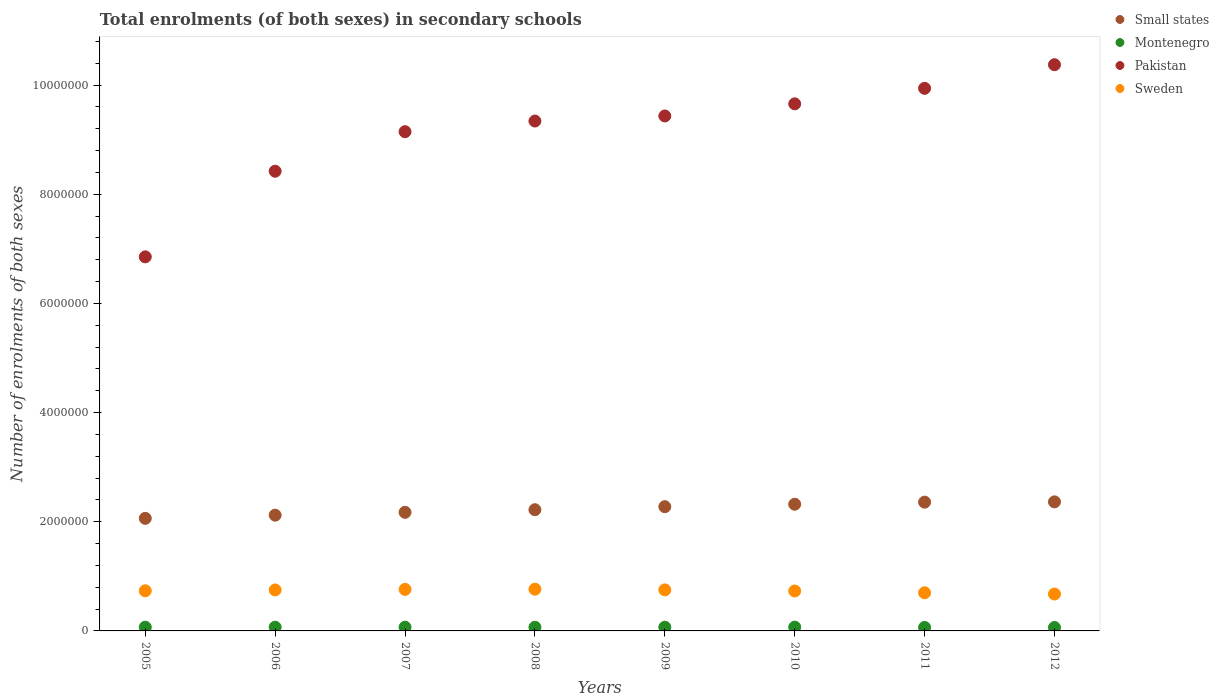How many different coloured dotlines are there?
Your response must be concise. 4. Is the number of dotlines equal to the number of legend labels?
Your answer should be compact. Yes. What is the number of enrolments in secondary schools in Small states in 2012?
Offer a terse response. 2.36e+06. Across all years, what is the maximum number of enrolments in secondary schools in Montenegro?
Keep it short and to the point. 6.96e+04. Across all years, what is the minimum number of enrolments in secondary schools in Pakistan?
Your response must be concise. 6.85e+06. In which year was the number of enrolments in secondary schools in Montenegro maximum?
Keep it short and to the point. 2010. In which year was the number of enrolments in secondary schools in Montenegro minimum?
Your answer should be very brief. 2012. What is the total number of enrolments in secondary schools in Small states in the graph?
Make the answer very short. 1.79e+07. What is the difference between the number of enrolments in secondary schools in Small states in 2006 and that in 2012?
Ensure brevity in your answer.  -2.44e+05. What is the difference between the number of enrolments in secondary schools in Pakistan in 2012 and the number of enrolments in secondary schools in Montenegro in 2009?
Provide a short and direct response. 1.03e+07. What is the average number of enrolments in secondary schools in Pakistan per year?
Your response must be concise. 9.14e+06. In the year 2006, what is the difference between the number of enrolments in secondary schools in Montenegro and number of enrolments in secondary schools in Small states?
Keep it short and to the point. -2.05e+06. In how many years, is the number of enrolments in secondary schools in Montenegro greater than 4400000?
Your answer should be very brief. 0. What is the ratio of the number of enrolments in secondary schools in Small states in 2007 to that in 2011?
Provide a short and direct response. 0.92. Is the number of enrolments in secondary schools in Montenegro in 2007 less than that in 2008?
Offer a terse response. No. What is the difference between the highest and the second highest number of enrolments in secondary schools in Sweden?
Your response must be concise. 3773. What is the difference between the highest and the lowest number of enrolments in secondary schools in Pakistan?
Provide a succinct answer. 3.52e+06. Is it the case that in every year, the sum of the number of enrolments in secondary schools in Montenegro and number of enrolments in secondary schools in Small states  is greater than the number of enrolments in secondary schools in Pakistan?
Give a very brief answer. No. Is the number of enrolments in secondary schools in Pakistan strictly less than the number of enrolments in secondary schools in Montenegro over the years?
Make the answer very short. No. How many dotlines are there?
Give a very brief answer. 4. Are the values on the major ticks of Y-axis written in scientific E-notation?
Keep it short and to the point. No. Does the graph contain any zero values?
Make the answer very short. No. How are the legend labels stacked?
Your answer should be compact. Vertical. What is the title of the graph?
Ensure brevity in your answer.  Total enrolments (of both sexes) in secondary schools. Does "Palau" appear as one of the legend labels in the graph?
Keep it short and to the point. No. What is the label or title of the X-axis?
Ensure brevity in your answer.  Years. What is the label or title of the Y-axis?
Offer a terse response. Number of enrolments of both sexes. What is the Number of enrolments of both sexes of Small states in 2005?
Offer a very short reply. 2.06e+06. What is the Number of enrolments of both sexes in Montenegro in 2005?
Keep it short and to the point. 6.85e+04. What is the Number of enrolments of both sexes in Pakistan in 2005?
Make the answer very short. 6.85e+06. What is the Number of enrolments of both sexes in Sweden in 2005?
Your answer should be compact. 7.35e+05. What is the Number of enrolments of both sexes in Small states in 2006?
Make the answer very short. 2.12e+06. What is the Number of enrolments of both sexes in Montenegro in 2006?
Keep it short and to the point. 6.82e+04. What is the Number of enrolments of both sexes in Pakistan in 2006?
Offer a very short reply. 8.42e+06. What is the Number of enrolments of both sexes in Sweden in 2006?
Give a very brief answer. 7.51e+05. What is the Number of enrolments of both sexes in Small states in 2007?
Offer a terse response. 2.17e+06. What is the Number of enrolments of both sexes of Montenegro in 2007?
Your answer should be very brief. 6.77e+04. What is the Number of enrolments of both sexes in Pakistan in 2007?
Your answer should be very brief. 9.15e+06. What is the Number of enrolments of both sexes of Sweden in 2007?
Offer a terse response. 7.60e+05. What is the Number of enrolments of both sexes in Small states in 2008?
Give a very brief answer. 2.22e+06. What is the Number of enrolments of both sexes in Montenegro in 2008?
Provide a succinct answer. 6.70e+04. What is the Number of enrolments of both sexes in Pakistan in 2008?
Your response must be concise. 9.34e+06. What is the Number of enrolments of both sexes of Sweden in 2008?
Offer a very short reply. 7.64e+05. What is the Number of enrolments of both sexes of Small states in 2009?
Make the answer very short. 2.28e+06. What is the Number of enrolments of both sexes in Montenegro in 2009?
Your answer should be compact. 6.81e+04. What is the Number of enrolments of both sexes in Pakistan in 2009?
Your answer should be very brief. 9.43e+06. What is the Number of enrolments of both sexes in Sweden in 2009?
Make the answer very short. 7.52e+05. What is the Number of enrolments of both sexes of Small states in 2010?
Offer a very short reply. 2.32e+06. What is the Number of enrolments of both sexes of Montenegro in 2010?
Your response must be concise. 6.96e+04. What is the Number of enrolments of both sexes of Pakistan in 2010?
Provide a short and direct response. 9.65e+06. What is the Number of enrolments of both sexes in Sweden in 2010?
Provide a succinct answer. 7.31e+05. What is the Number of enrolments of both sexes in Small states in 2011?
Keep it short and to the point. 2.36e+06. What is the Number of enrolments of both sexes of Montenegro in 2011?
Your answer should be compact. 6.42e+04. What is the Number of enrolments of both sexes in Pakistan in 2011?
Ensure brevity in your answer.  9.94e+06. What is the Number of enrolments of both sexes in Sweden in 2011?
Keep it short and to the point. 6.99e+05. What is the Number of enrolments of both sexes of Small states in 2012?
Offer a terse response. 2.36e+06. What is the Number of enrolments of both sexes of Montenegro in 2012?
Ensure brevity in your answer.  6.30e+04. What is the Number of enrolments of both sexes in Pakistan in 2012?
Ensure brevity in your answer.  1.04e+07. What is the Number of enrolments of both sexes of Sweden in 2012?
Give a very brief answer. 6.76e+05. Across all years, what is the maximum Number of enrolments of both sexes in Small states?
Offer a very short reply. 2.36e+06. Across all years, what is the maximum Number of enrolments of both sexes of Montenegro?
Keep it short and to the point. 6.96e+04. Across all years, what is the maximum Number of enrolments of both sexes of Pakistan?
Your answer should be very brief. 1.04e+07. Across all years, what is the maximum Number of enrolments of both sexes of Sweden?
Provide a succinct answer. 7.64e+05. Across all years, what is the minimum Number of enrolments of both sexes in Small states?
Make the answer very short. 2.06e+06. Across all years, what is the minimum Number of enrolments of both sexes of Montenegro?
Provide a succinct answer. 6.30e+04. Across all years, what is the minimum Number of enrolments of both sexes in Pakistan?
Offer a very short reply. 6.85e+06. Across all years, what is the minimum Number of enrolments of both sexes in Sweden?
Provide a succinct answer. 6.76e+05. What is the total Number of enrolments of both sexes in Small states in the graph?
Provide a short and direct response. 1.79e+07. What is the total Number of enrolments of both sexes of Montenegro in the graph?
Offer a very short reply. 5.36e+05. What is the total Number of enrolments of both sexes of Pakistan in the graph?
Provide a succinct answer. 7.32e+07. What is the total Number of enrolments of both sexes of Sweden in the graph?
Your answer should be compact. 5.87e+06. What is the difference between the Number of enrolments of both sexes of Small states in 2005 and that in 2006?
Your answer should be very brief. -5.83e+04. What is the difference between the Number of enrolments of both sexes of Montenegro in 2005 and that in 2006?
Provide a succinct answer. 253. What is the difference between the Number of enrolments of both sexes in Pakistan in 2005 and that in 2006?
Ensure brevity in your answer.  -1.57e+06. What is the difference between the Number of enrolments of both sexes of Sweden in 2005 and that in 2006?
Your answer should be compact. -1.51e+04. What is the difference between the Number of enrolments of both sexes of Small states in 2005 and that in 2007?
Give a very brief answer. -1.10e+05. What is the difference between the Number of enrolments of both sexes of Montenegro in 2005 and that in 2007?
Provide a succinct answer. 788. What is the difference between the Number of enrolments of both sexes in Pakistan in 2005 and that in 2007?
Your response must be concise. -2.29e+06. What is the difference between the Number of enrolments of both sexes in Sweden in 2005 and that in 2007?
Give a very brief answer. -2.50e+04. What is the difference between the Number of enrolments of both sexes in Small states in 2005 and that in 2008?
Provide a short and direct response. -1.58e+05. What is the difference between the Number of enrolments of both sexes of Montenegro in 2005 and that in 2008?
Keep it short and to the point. 1456. What is the difference between the Number of enrolments of both sexes of Pakistan in 2005 and that in 2008?
Your response must be concise. -2.49e+06. What is the difference between the Number of enrolments of both sexes in Sweden in 2005 and that in 2008?
Provide a short and direct response. -2.88e+04. What is the difference between the Number of enrolments of both sexes in Small states in 2005 and that in 2009?
Your answer should be very brief. -2.14e+05. What is the difference between the Number of enrolments of both sexes in Montenegro in 2005 and that in 2009?
Give a very brief answer. 336. What is the difference between the Number of enrolments of both sexes of Pakistan in 2005 and that in 2009?
Make the answer very short. -2.58e+06. What is the difference between the Number of enrolments of both sexes of Sweden in 2005 and that in 2009?
Your response must be concise. -1.63e+04. What is the difference between the Number of enrolments of both sexes of Small states in 2005 and that in 2010?
Your response must be concise. -2.59e+05. What is the difference between the Number of enrolments of both sexes of Montenegro in 2005 and that in 2010?
Your answer should be very brief. -1148. What is the difference between the Number of enrolments of both sexes of Pakistan in 2005 and that in 2010?
Ensure brevity in your answer.  -2.80e+06. What is the difference between the Number of enrolments of both sexes in Sweden in 2005 and that in 2010?
Keep it short and to the point. 4221. What is the difference between the Number of enrolments of both sexes in Small states in 2005 and that in 2011?
Provide a short and direct response. -2.97e+05. What is the difference between the Number of enrolments of both sexes of Montenegro in 2005 and that in 2011?
Give a very brief answer. 4307. What is the difference between the Number of enrolments of both sexes of Pakistan in 2005 and that in 2011?
Your answer should be very brief. -3.09e+06. What is the difference between the Number of enrolments of both sexes in Sweden in 2005 and that in 2011?
Your answer should be compact. 3.65e+04. What is the difference between the Number of enrolments of both sexes in Small states in 2005 and that in 2012?
Make the answer very short. -3.02e+05. What is the difference between the Number of enrolments of both sexes in Montenegro in 2005 and that in 2012?
Keep it short and to the point. 5458. What is the difference between the Number of enrolments of both sexes in Pakistan in 2005 and that in 2012?
Your answer should be compact. -3.52e+06. What is the difference between the Number of enrolments of both sexes of Sweden in 2005 and that in 2012?
Your response must be concise. 5.97e+04. What is the difference between the Number of enrolments of both sexes of Small states in 2006 and that in 2007?
Offer a terse response. -5.19e+04. What is the difference between the Number of enrolments of both sexes of Montenegro in 2006 and that in 2007?
Offer a terse response. 535. What is the difference between the Number of enrolments of both sexes of Pakistan in 2006 and that in 2007?
Provide a short and direct response. -7.24e+05. What is the difference between the Number of enrolments of both sexes of Sweden in 2006 and that in 2007?
Provide a short and direct response. -9924. What is the difference between the Number of enrolments of both sexes of Small states in 2006 and that in 2008?
Offer a very short reply. -9.96e+04. What is the difference between the Number of enrolments of both sexes in Montenegro in 2006 and that in 2008?
Offer a very short reply. 1203. What is the difference between the Number of enrolments of both sexes of Pakistan in 2006 and that in 2008?
Keep it short and to the point. -9.19e+05. What is the difference between the Number of enrolments of both sexes of Sweden in 2006 and that in 2008?
Offer a very short reply. -1.37e+04. What is the difference between the Number of enrolments of both sexes of Small states in 2006 and that in 2009?
Provide a succinct answer. -1.55e+05. What is the difference between the Number of enrolments of both sexes in Montenegro in 2006 and that in 2009?
Your answer should be very brief. 83. What is the difference between the Number of enrolments of both sexes of Pakistan in 2006 and that in 2009?
Provide a succinct answer. -1.01e+06. What is the difference between the Number of enrolments of both sexes in Sweden in 2006 and that in 2009?
Ensure brevity in your answer.  -1259. What is the difference between the Number of enrolments of both sexes of Small states in 2006 and that in 2010?
Offer a very short reply. -2.00e+05. What is the difference between the Number of enrolments of both sexes of Montenegro in 2006 and that in 2010?
Offer a terse response. -1401. What is the difference between the Number of enrolments of both sexes of Pakistan in 2006 and that in 2010?
Provide a short and direct response. -1.23e+06. What is the difference between the Number of enrolments of both sexes of Sweden in 2006 and that in 2010?
Your answer should be compact. 1.93e+04. What is the difference between the Number of enrolments of both sexes of Small states in 2006 and that in 2011?
Provide a short and direct response. -2.38e+05. What is the difference between the Number of enrolments of both sexes in Montenegro in 2006 and that in 2011?
Provide a succinct answer. 4054. What is the difference between the Number of enrolments of both sexes in Pakistan in 2006 and that in 2011?
Your answer should be very brief. -1.52e+06. What is the difference between the Number of enrolments of both sexes of Sweden in 2006 and that in 2011?
Ensure brevity in your answer.  5.16e+04. What is the difference between the Number of enrolments of both sexes in Small states in 2006 and that in 2012?
Offer a terse response. -2.44e+05. What is the difference between the Number of enrolments of both sexes of Montenegro in 2006 and that in 2012?
Your response must be concise. 5205. What is the difference between the Number of enrolments of both sexes of Pakistan in 2006 and that in 2012?
Offer a very short reply. -1.95e+06. What is the difference between the Number of enrolments of both sexes of Sweden in 2006 and that in 2012?
Provide a succinct answer. 7.48e+04. What is the difference between the Number of enrolments of both sexes of Small states in 2007 and that in 2008?
Give a very brief answer. -4.77e+04. What is the difference between the Number of enrolments of both sexes of Montenegro in 2007 and that in 2008?
Offer a very short reply. 668. What is the difference between the Number of enrolments of both sexes in Pakistan in 2007 and that in 2008?
Ensure brevity in your answer.  -1.95e+05. What is the difference between the Number of enrolments of both sexes of Sweden in 2007 and that in 2008?
Offer a terse response. -3773. What is the difference between the Number of enrolments of both sexes of Small states in 2007 and that in 2009?
Provide a short and direct response. -1.03e+05. What is the difference between the Number of enrolments of both sexes in Montenegro in 2007 and that in 2009?
Give a very brief answer. -452. What is the difference between the Number of enrolments of both sexes in Pakistan in 2007 and that in 2009?
Provide a succinct answer. -2.88e+05. What is the difference between the Number of enrolments of both sexes of Sweden in 2007 and that in 2009?
Keep it short and to the point. 8665. What is the difference between the Number of enrolments of both sexes in Small states in 2007 and that in 2010?
Provide a short and direct response. -1.48e+05. What is the difference between the Number of enrolments of both sexes in Montenegro in 2007 and that in 2010?
Give a very brief answer. -1936. What is the difference between the Number of enrolments of both sexes in Pakistan in 2007 and that in 2010?
Offer a very short reply. -5.10e+05. What is the difference between the Number of enrolments of both sexes in Sweden in 2007 and that in 2010?
Give a very brief answer. 2.92e+04. What is the difference between the Number of enrolments of both sexes of Small states in 2007 and that in 2011?
Your answer should be very brief. -1.86e+05. What is the difference between the Number of enrolments of both sexes of Montenegro in 2007 and that in 2011?
Your answer should be compact. 3519. What is the difference between the Number of enrolments of both sexes of Pakistan in 2007 and that in 2011?
Your response must be concise. -7.94e+05. What is the difference between the Number of enrolments of both sexes of Sweden in 2007 and that in 2011?
Your answer should be compact. 6.15e+04. What is the difference between the Number of enrolments of both sexes in Small states in 2007 and that in 2012?
Give a very brief answer. -1.92e+05. What is the difference between the Number of enrolments of both sexes of Montenegro in 2007 and that in 2012?
Your answer should be compact. 4670. What is the difference between the Number of enrolments of both sexes of Pakistan in 2007 and that in 2012?
Offer a very short reply. -1.23e+06. What is the difference between the Number of enrolments of both sexes in Sweden in 2007 and that in 2012?
Your answer should be very brief. 8.47e+04. What is the difference between the Number of enrolments of both sexes in Small states in 2008 and that in 2009?
Your answer should be compact. -5.58e+04. What is the difference between the Number of enrolments of both sexes of Montenegro in 2008 and that in 2009?
Offer a terse response. -1120. What is the difference between the Number of enrolments of both sexes of Pakistan in 2008 and that in 2009?
Provide a succinct answer. -9.30e+04. What is the difference between the Number of enrolments of both sexes of Sweden in 2008 and that in 2009?
Your response must be concise. 1.24e+04. What is the difference between the Number of enrolments of both sexes in Small states in 2008 and that in 2010?
Offer a terse response. -1.01e+05. What is the difference between the Number of enrolments of both sexes in Montenegro in 2008 and that in 2010?
Offer a terse response. -2604. What is the difference between the Number of enrolments of both sexes of Pakistan in 2008 and that in 2010?
Your answer should be very brief. -3.15e+05. What is the difference between the Number of enrolments of both sexes in Sweden in 2008 and that in 2010?
Keep it short and to the point. 3.30e+04. What is the difference between the Number of enrolments of both sexes in Small states in 2008 and that in 2011?
Your answer should be compact. -1.39e+05. What is the difference between the Number of enrolments of both sexes of Montenegro in 2008 and that in 2011?
Keep it short and to the point. 2851. What is the difference between the Number of enrolments of both sexes in Pakistan in 2008 and that in 2011?
Keep it short and to the point. -5.99e+05. What is the difference between the Number of enrolments of both sexes in Sweden in 2008 and that in 2011?
Offer a terse response. 6.53e+04. What is the difference between the Number of enrolments of both sexes in Small states in 2008 and that in 2012?
Offer a very short reply. -1.44e+05. What is the difference between the Number of enrolments of both sexes of Montenegro in 2008 and that in 2012?
Keep it short and to the point. 4002. What is the difference between the Number of enrolments of both sexes of Pakistan in 2008 and that in 2012?
Offer a terse response. -1.03e+06. What is the difference between the Number of enrolments of both sexes of Sweden in 2008 and that in 2012?
Make the answer very short. 8.85e+04. What is the difference between the Number of enrolments of both sexes in Small states in 2009 and that in 2010?
Keep it short and to the point. -4.49e+04. What is the difference between the Number of enrolments of both sexes in Montenegro in 2009 and that in 2010?
Ensure brevity in your answer.  -1484. What is the difference between the Number of enrolments of both sexes of Pakistan in 2009 and that in 2010?
Ensure brevity in your answer.  -2.22e+05. What is the difference between the Number of enrolments of both sexes of Sweden in 2009 and that in 2010?
Provide a succinct answer. 2.06e+04. What is the difference between the Number of enrolments of both sexes in Small states in 2009 and that in 2011?
Give a very brief answer. -8.30e+04. What is the difference between the Number of enrolments of both sexes in Montenegro in 2009 and that in 2011?
Make the answer very short. 3971. What is the difference between the Number of enrolments of both sexes of Pakistan in 2009 and that in 2011?
Offer a very short reply. -5.06e+05. What is the difference between the Number of enrolments of both sexes in Sweden in 2009 and that in 2011?
Provide a succinct answer. 5.29e+04. What is the difference between the Number of enrolments of both sexes in Small states in 2009 and that in 2012?
Your answer should be very brief. -8.83e+04. What is the difference between the Number of enrolments of both sexes in Montenegro in 2009 and that in 2012?
Offer a very short reply. 5122. What is the difference between the Number of enrolments of both sexes in Pakistan in 2009 and that in 2012?
Your answer should be very brief. -9.39e+05. What is the difference between the Number of enrolments of both sexes of Sweden in 2009 and that in 2012?
Offer a very short reply. 7.60e+04. What is the difference between the Number of enrolments of both sexes of Small states in 2010 and that in 2011?
Provide a succinct answer. -3.81e+04. What is the difference between the Number of enrolments of both sexes of Montenegro in 2010 and that in 2011?
Keep it short and to the point. 5455. What is the difference between the Number of enrolments of both sexes of Pakistan in 2010 and that in 2011?
Make the answer very short. -2.84e+05. What is the difference between the Number of enrolments of both sexes of Sweden in 2010 and that in 2011?
Your answer should be very brief. 3.23e+04. What is the difference between the Number of enrolments of both sexes in Small states in 2010 and that in 2012?
Your answer should be compact. -4.35e+04. What is the difference between the Number of enrolments of both sexes in Montenegro in 2010 and that in 2012?
Your answer should be very brief. 6606. What is the difference between the Number of enrolments of both sexes in Pakistan in 2010 and that in 2012?
Your answer should be compact. -7.17e+05. What is the difference between the Number of enrolments of both sexes in Sweden in 2010 and that in 2012?
Make the answer very short. 5.55e+04. What is the difference between the Number of enrolments of both sexes of Small states in 2011 and that in 2012?
Provide a short and direct response. -5352.25. What is the difference between the Number of enrolments of both sexes in Montenegro in 2011 and that in 2012?
Your answer should be very brief. 1151. What is the difference between the Number of enrolments of both sexes in Pakistan in 2011 and that in 2012?
Your answer should be very brief. -4.32e+05. What is the difference between the Number of enrolments of both sexes of Sweden in 2011 and that in 2012?
Make the answer very short. 2.32e+04. What is the difference between the Number of enrolments of both sexes in Small states in 2005 and the Number of enrolments of both sexes in Montenegro in 2006?
Provide a succinct answer. 1.99e+06. What is the difference between the Number of enrolments of both sexes in Small states in 2005 and the Number of enrolments of both sexes in Pakistan in 2006?
Your answer should be compact. -6.36e+06. What is the difference between the Number of enrolments of both sexes of Small states in 2005 and the Number of enrolments of both sexes of Sweden in 2006?
Your answer should be compact. 1.31e+06. What is the difference between the Number of enrolments of both sexes in Montenegro in 2005 and the Number of enrolments of both sexes in Pakistan in 2006?
Your answer should be compact. -8.35e+06. What is the difference between the Number of enrolments of both sexes in Montenegro in 2005 and the Number of enrolments of both sexes in Sweden in 2006?
Offer a very short reply. -6.82e+05. What is the difference between the Number of enrolments of both sexes in Pakistan in 2005 and the Number of enrolments of both sexes in Sweden in 2006?
Your answer should be compact. 6.10e+06. What is the difference between the Number of enrolments of both sexes in Small states in 2005 and the Number of enrolments of both sexes in Montenegro in 2007?
Your response must be concise. 1.99e+06. What is the difference between the Number of enrolments of both sexes of Small states in 2005 and the Number of enrolments of both sexes of Pakistan in 2007?
Provide a short and direct response. -7.08e+06. What is the difference between the Number of enrolments of both sexes in Small states in 2005 and the Number of enrolments of both sexes in Sweden in 2007?
Provide a succinct answer. 1.30e+06. What is the difference between the Number of enrolments of both sexes in Montenegro in 2005 and the Number of enrolments of both sexes in Pakistan in 2007?
Offer a terse response. -9.08e+06. What is the difference between the Number of enrolments of both sexes in Montenegro in 2005 and the Number of enrolments of both sexes in Sweden in 2007?
Keep it short and to the point. -6.92e+05. What is the difference between the Number of enrolments of both sexes of Pakistan in 2005 and the Number of enrolments of both sexes of Sweden in 2007?
Provide a succinct answer. 6.09e+06. What is the difference between the Number of enrolments of both sexes of Small states in 2005 and the Number of enrolments of both sexes of Montenegro in 2008?
Make the answer very short. 2.00e+06. What is the difference between the Number of enrolments of both sexes of Small states in 2005 and the Number of enrolments of both sexes of Pakistan in 2008?
Your response must be concise. -7.28e+06. What is the difference between the Number of enrolments of both sexes in Small states in 2005 and the Number of enrolments of both sexes in Sweden in 2008?
Your answer should be very brief. 1.30e+06. What is the difference between the Number of enrolments of both sexes in Montenegro in 2005 and the Number of enrolments of both sexes in Pakistan in 2008?
Your response must be concise. -9.27e+06. What is the difference between the Number of enrolments of both sexes of Montenegro in 2005 and the Number of enrolments of both sexes of Sweden in 2008?
Provide a short and direct response. -6.96e+05. What is the difference between the Number of enrolments of both sexes of Pakistan in 2005 and the Number of enrolments of both sexes of Sweden in 2008?
Your answer should be very brief. 6.09e+06. What is the difference between the Number of enrolments of both sexes in Small states in 2005 and the Number of enrolments of both sexes in Montenegro in 2009?
Ensure brevity in your answer.  1.99e+06. What is the difference between the Number of enrolments of both sexes of Small states in 2005 and the Number of enrolments of both sexes of Pakistan in 2009?
Ensure brevity in your answer.  -7.37e+06. What is the difference between the Number of enrolments of both sexes of Small states in 2005 and the Number of enrolments of both sexes of Sweden in 2009?
Offer a very short reply. 1.31e+06. What is the difference between the Number of enrolments of both sexes in Montenegro in 2005 and the Number of enrolments of both sexes in Pakistan in 2009?
Keep it short and to the point. -9.36e+06. What is the difference between the Number of enrolments of both sexes of Montenegro in 2005 and the Number of enrolments of both sexes of Sweden in 2009?
Give a very brief answer. -6.83e+05. What is the difference between the Number of enrolments of both sexes of Pakistan in 2005 and the Number of enrolments of both sexes of Sweden in 2009?
Provide a short and direct response. 6.10e+06. What is the difference between the Number of enrolments of both sexes in Small states in 2005 and the Number of enrolments of both sexes in Montenegro in 2010?
Keep it short and to the point. 1.99e+06. What is the difference between the Number of enrolments of both sexes of Small states in 2005 and the Number of enrolments of both sexes of Pakistan in 2010?
Your answer should be very brief. -7.59e+06. What is the difference between the Number of enrolments of both sexes in Small states in 2005 and the Number of enrolments of both sexes in Sweden in 2010?
Ensure brevity in your answer.  1.33e+06. What is the difference between the Number of enrolments of both sexes of Montenegro in 2005 and the Number of enrolments of both sexes of Pakistan in 2010?
Keep it short and to the point. -9.59e+06. What is the difference between the Number of enrolments of both sexes of Montenegro in 2005 and the Number of enrolments of both sexes of Sweden in 2010?
Your answer should be compact. -6.63e+05. What is the difference between the Number of enrolments of both sexes of Pakistan in 2005 and the Number of enrolments of both sexes of Sweden in 2010?
Offer a very short reply. 6.12e+06. What is the difference between the Number of enrolments of both sexes of Small states in 2005 and the Number of enrolments of both sexes of Montenegro in 2011?
Offer a terse response. 2.00e+06. What is the difference between the Number of enrolments of both sexes of Small states in 2005 and the Number of enrolments of both sexes of Pakistan in 2011?
Offer a very short reply. -7.88e+06. What is the difference between the Number of enrolments of both sexes in Small states in 2005 and the Number of enrolments of both sexes in Sweden in 2011?
Your response must be concise. 1.36e+06. What is the difference between the Number of enrolments of both sexes of Montenegro in 2005 and the Number of enrolments of both sexes of Pakistan in 2011?
Ensure brevity in your answer.  -9.87e+06. What is the difference between the Number of enrolments of both sexes of Montenegro in 2005 and the Number of enrolments of both sexes of Sweden in 2011?
Ensure brevity in your answer.  -6.30e+05. What is the difference between the Number of enrolments of both sexes in Pakistan in 2005 and the Number of enrolments of both sexes in Sweden in 2011?
Provide a short and direct response. 6.15e+06. What is the difference between the Number of enrolments of both sexes of Small states in 2005 and the Number of enrolments of both sexes of Montenegro in 2012?
Make the answer very short. 2.00e+06. What is the difference between the Number of enrolments of both sexes in Small states in 2005 and the Number of enrolments of both sexes in Pakistan in 2012?
Give a very brief answer. -8.31e+06. What is the difference between the Number of enrolments of both sexes of Small states in 2005 and the Number of enrolments of both sexes of Sweden in 2012?
Provide a short and direct response. 1.39e+06. What is the difference between the Number of enrolments of both sexes of Montenegro in 2005 and the Number of enrolments of both sexes of Pakistan in 2012?
Ensure brevity in your answer.  -1.03e+07. What is the difference between the Number of enrolments of both sexes in Montenegro in 2005 and the Number of enrolments of both sexes in Sweden in 2012?
Offer a terse response. -6.07e+05. What is the difference between the Number of enrolments of both sexes in Pakistan in 2005 and the Number of enrolments of both sexes in Sweden in 2012?
Offer a very short reply. 6.18e+06. What is the difference between the Number of enrolments of both sexes in Small states in 2006 and the Number of enrolments of both sexes in Montenegro in 2007?
Give a very brief answer. 2.05e+06. What is the difference between the Number of enrolments of both sexes in Small states in 2006 and the Number of enrolments of both sexes in Pakistan in 2007?
Provide a short and direct response. -7.02e+06. What is the difference between the Number of enrolments of both sexes of Small states in 2006 and the Number of enrolments of both sexes of Sweden in 2007?
Your answer should be compact. 1.36e+06. What is the difference between the Number of enrolments of both sexes of Montenegro in 2006 and the Number of enrolments of both sexes of Pakistan in 2007?
Provide a short and direct response. -9.08e+06. What is the difference between the Number of enrolments of both sexes in Montenegro in 2006 and the Number of enrolments of both sexes in Sweden in 2007?
Your answer should be very brief. -6.92e+05. What is the difference between the Number of enrolments of both sexes in Pakistan in 2006 and the Number of enrolments of both sexes in Sweden in 2007?
Provide a succinct answer. 7.66e+06. What is the difference between the Number of enrolments of both sexes of Small states in 2006 and the Number of enrolments of both sexes of Montenegro in 2008?
Give a very brief answer. 2.05e+06. What is the difference between the Number of enrolments of both sexes of Small states in 2006 and the Number of enrolments of both sexes of Pakistan in 2008?
Make the answer very short. -7.22e+06. What is the difference between the Number of enrolments of both sexes of Small states in 2006 and the Number of enrolments of both sexes of Sweden in 2008?
Your answer should be very brief. 1.36e+06. What is the difference between the Number of enrolments of both sexes in Montenegro in 2006 and the Number of enrolments of both sexes in Pakistan in 2008?
Ensure brevity in your answer.  -9.27e+06. What is the difference between the Number of enrolments of both sexes of Montenegro in 2006 and the Number of enrolments of both sexes of Sweden in 2008?
Keep it short and to the point. -6.96e+05. What is the difference between the Number of enrolments of both sexes of Pakistan in 2006 and the Number of enrolments of both sexes of Sweden in 2008?
Your answer should be very brief. 7.66e+06. What is the difference between the Number of enrolments of both sexes of Small states in 2006 and the Number of enrolments of both sexes of Montenegro in 2009?
Ensure brevity in your answer.  2.05e+06. What is the difference between the Number of enrolments of both sexes of Small states in 2006 and the Number of enrolments of both sexes of Pakistan in 2009?
Give a very brief answer. -7.31e+06. What is the difference between the Number of enrolments of both sexes of Small states in 2006 and the Number of enrolments of both sexes of Sweden in 2009?
Provide a short and direct response. 1.37e+06. What is the difference between the Number of enrolments of both sexes in Montenegro in 2006 and the Number of enrolments of both sexes in Pakistan in 2009?
Your answer should be compact. -9.36e+06. What is the difference between the Number of enrolments of both sexes in Montenegro in 2006 and the Number of enrolments of both sexes in Sweden in 2009?
Make the answer very short. -6.84e+05. What is the difference between the Number of enrolments of both sexes of Pakistan in 2006 and the Number of enrolments of both sexes of Sweden in 2009?
Your answer should be compact. 7.67e+06. What is the difference between the Number of enrolments of both sexes in Small states in 2006 and the Number of enrolments of both sexes in Montenegro in 2010?
Make the answer very short. 2.05e+06. What is the difference between the Number of enrolments of both sexes in Small states in 2006 and the Number of enrolments of both sexes in Pakistan in 2010?
Keep it short and to the point. -7.53e+06. What is the difference between the Number of enrolments of both sexes of Small states in 2006 and the Number of enrolments of both sexes of Sweden in 2010?
Provide a short and direct response. 1.39e+06. What is the difference between the Number of enrolments of both sexes of Montenegro in 2006 and the Number of enrolments of both sexes of Pakistan in 2010?
Your answer should be compact. -9.59e+06. What is the difference between the Number of enrolments of both sexes of Montenegro in 2006 and the Number of enrolments of both sexes of Sweden in 2010?
Offer a terse response. -6.63e+05. What is the difference between the Number of enrolments of both sexes of Pakistan in 2006 and the Number of enrolments of both sexes of Sweden in 2010?
Offer a terse response. 7.69e+06. What is the difference between the Number of enrolments of both sexes in Small states in 2006 and the Number of enrolments of both sexes in Montenegro in 2011?
Your answer should be very brief. 2.06e+06. What is the difference between the Number of enrolments of both sexes in Small states in 2006 and the Number of enrolments of both sexes in Pakistan in 2011?
Make the answer very short. -7.82e+06. What is the difference between the Number of enrolments of both sexes of Small states in 2006 and the Number of enrolments of both sexes of Sweden in 2011?
Offer a terse response. 1.42e+06. What is the difference between the Number of enrolments of both sexes in Montenegro in 2006 and the Number of enrolments of both sexes in Pakistan in 2011?
Offer a terse response. -9.87e+06. What is the difference between the Number of enrolments of both sexes of Montenegro in 2006 and the Number of enrolments of both sexes of Sweden in 2011?
Your answer should be compact. -6.31e+05. What is the difference between the Number of enrolments of both sexes in Pakistan in 2006 and the Number of enrolments of both sexes in Sweden in 2011?
Make the answer very short. 7.72e+06. What is the difference between the Number of enrolments of both sexes in Small states in 2006 and the Number of enrolments of both sexes in Montenegro in 2012?
Provide a short and direct response. 2.06e+06. What is the difference between the Number of enrolments of both sexes of Small states in 2006 and the Number of enrolments of both sexes of Pakistan in 2012?
Make the answer very short. -8.25e+06. What is the difference between the Number of enrolments of both sexes of Small states in 2006 and the Number of enrolments of both sexes of Sweden in 2012?
Give a very brief answer. 1.44e+06. What is the difference between the Number of enrolments of both sexes of Montenegro in 2006 and the Number of enrolments of both sexes of Pakistan in 2012?
Make the answer very short. -1.03e+07. What is the difference between the Number of enrolments of both sexes in Montenegro in 2006 and the Number of enrolments of both sexes in Sweden in 2012?
Provide a short and direct response. -6.08e+05. What is the difference between the Number of enrolments of both sexes in Pakistan in 2006 and the Number of enrolments of both sexes in Sweden in 2012?
Ensure brevity in your answer.  7.75e+06. What is the difference between the Number of enrolments of both sexes in Small states in 2007 and the Number of enrolments of both sexes in Montenegro in 2008?
Your answer should be very brief. 2.11e+06. What is the difference between the Number of enrolments of both sexes of Small states in 2007 and the Number of enrolments of both sexes of Pakistan in 2008?
Ensure brevity in your answer.  -7.17e+06. What is the difference between the Number of enrolments of both sexes in Small states in 2007 and the Number of enrolments of both sexes in Sweden in 2008?
Keep it short and to the point. 1.41e+06. What is the difference between the Number of enrolments of both sexes of Montenegro in 2007 and the Number of enrolments of both sexes of Pakistan in 2008?
Provide a short and direct response. -9.27e+06. What is the difference between the Number of enrolments of both sexes of Montenegro in 2007 and the Number of enrolments of both sexes of Sweden in 2008?
Ensure brevity in your answer.  -6.97e+05. What is the difference between the Number of enrolments of both sexes in Pakistan in 2007 and the Number of enrolments of both sexes in Sweden in 2008?
Keep it short and to the point. 8.38e+06. What is the difference between the Number of enrolments of both sexes of Small states in 2007 and the Number of enrolments of both sexes of Montenegro in 2009?
Your answer should be compact. 2.10e+06. What is the difference between the Number of enrolments of both sexes of Small states in 2007 and the Number of enrolments of both sexes of Pakistan in 2009?
Keep it short and to the point. -7.26e+06. What is the difference between the Number of enrolments of both sexes in Small states in 2007 and the Number of enrolments of both sexes in Sweden in 2009?
Your answer should be very brief. 1.42e+06. What is the difference between the Number of enrolments of both sexes in Montenegro in 2007 and the Number of enrolments of both sexes in Pakistan in 2009?
Your answer should be compact. -9.37e+06. What is the difference between the Number of enrolments of both sexes of Montenegro in 2007 and the Number of enrolments of both sexes of Sweden in 2009?
Provide a succinct answer. -6.84e+05. What is the difference between the Number of enrolments of both sexes in Pakistan in 2007 and the Number of enrolments of both sexes in Sweden in 2009?
Offer a terse response. 8.39e+06. What is the difference between the Number of enrolments of both sexes of Small states in 2007 and the Number of enrolments of both sexes of Montenegro in 2010?
Keep it short and to the point. 2.10e+06. What is the difference between the Number of enrolments of both sexes of Small states in 2007 and the Number of enrolments of both sexes of Pakistan in 2010?
Make the answer very short. -7.48e+06. What is the difference between the Number of enrolments of both sexes in Small states in 2007 and the Number of enrolments of both sexes in Sweden in 2010?
Your response must be concise. 1.44e+06. What is the difference between the Number of enrolments of both sexes in Montenegro in 2007 and the Number of enrolments of both sexes in Pakistan in 2010?
Provide a short and direct response. -9.59e+06. What is the difference between the Number of enrolments of both sexes in Montenegro in 2007 and the Number of enrolments of both sexes in Sweden in 2010?
Your answer should be compact. -6.64e+05. What is the difference between the Number of enrolments of both sexes in Pakistan in 2007 and the Number of enrolments of both sexes in Sweden in 2010?
Provide a succinct answer. 8.41e+06. What is the difference between the Number of enrolments of both sexes in Small states in 2007 and the Number of enrolments of both sexes in Montenegro in 2011?
Your answer should be compact. 2.11e+06. What is the difference between the Number of enrolments of both sexes in Small states in 2007 and the Number of enrolments of both sexes in Pakistan in 2011?
Provide a short and direct response. -7.77e+06. What is the difference between the Number of enrolments of both sexes in Small states in 2007 and the Number of enrolments of both sexes in Sweden in 2011?
Offer a very short reply. 1.47e+06. What is the difference between the Number of enrolments of both sexes of Montenegro in 2007 and the Number of enrolments of both sexes of Pakistan in 2011?
Provide a short and direct response. -9.87e+06. What is the difference between the Number of enrolments of both sexes in Montenegro in 2007 and the Number of enrolments of both sexes in Sweden in 2011?
Provide a short and direct response. -6.31e+05. What is the difference between the Number of enrolments of both sexes of Pakistan in 2007 and the Number of enrolments of both sexes of Sweden in 2011?
Make the answer very short. 8.45e+06. What is the difference between the Number of enrolments of both sexes of Small states in 2007 and the Number of enrolments of both sexes of Montenegro in 2012?
Make the answer very short. 2.11e+06. What is the difference between the Number of enrolments of both sexes in Small states in 2007 and the Number of enrolments of both sexes in Pakistan in 2012?
Offer a very short reply. -8.20e+06. What is the difference between the Number of enrolments of both sexes in Small states in 2007 and the Number of enrolments of both sexes in Sweden in 2012?
Provide a succinct answer. 1.50e+06. What is the difference between the Number of enrolments of both sexes of Montenegro in 2007 and the Number of enrolments of both sexes of Pakistan in 2012?
Provide a succinct answer. -1.03e+07. What is the difference between the Number of enrolments of both sexes of Montenegro in 2007 and the Number of enrolments of both sexes of Sweden in 2012?
Your response must be concise. -6.08e+05. What is the difference between the Number of enrolments of both sexes of Pakistan in 2007 and the Number of enrolments of both sexes of Sweden in 2012?
Offer a very short reply. 8.47e+06. What is the difference between the Number of enrolments of both sexes in Small states in 2008 and the Number of enrolments of both sexes in Montenegro in 2009?
Offer a very short reply. 2.15e+06. What is the difference between the Number of enrolments of both sexes in Small states in 2008 and the Number of enrolments of both sexes in Pakistan in 2009?
Ensure brevity in your answer.  -7.21e+06. What is the difference between the Number of enrolments of both sexes of Small states in 2008 and the Number of enrolments of both sexes of Sweden in 2009?
Provide a short and direct response. 1.47e+06. What is the difference between the Number of enrolments of both sexes of Montenegro in 2008 and the Number of enrolments of both sexes of Pakistan in 2009?
Offer a terse response. -9.37e+06. What is the difference between the Number of enrolments of both sexes in Montenegro in 2008 and the Number of enrolments of both sexes in Sweden in 2009?
Your answer should be compact. -6.85e+05. What is the difference between the Number of enrolments of both sexes in Pakistan in 2008 and the Number of enrolments of both sexes in Sweden in 2009?
Your answer should be compact. 8.59e+06. What is the difference between the Number of enrolments of both sexes in Small states in 2008 and the Number of enrolments of both sexes in Montenegro in 2010?
Give a very brief answer. 2.15e+06. What is the difference between the Number of enrolments of both sexes of Small states in 2008 and the Number of enrolments of both sexes of Pakistan in 2010?
Your answer should be compact. -7.43e+06. What is the difference between the Number of enrolments of both sexes in Small states in 2008 and the Number of enrolments of both sexes in Sweden in 2010?
Offer a very short reply. 1.49e+06. What is the difference between the Number of enrolments of both sexes in Montenegro in 2008 and the Number of enrolments of both sexes in Pakistan in 2010?
Offer a very short reply. -9.59e+06. What is the difference between the Number of enrolments of both sexes in Montenegro in 2008 and the Number of enrolments of both sexes in Sweden in 2010?
Offer a very short reply. -6.64e+05. What is the difference between the Number of enrolments of both sexes in Pakistan in 2008 and the Number of enrolments of both sexes in Sweden in 2010?
Offer a very short reply. 8.61e+06. What is the difference between the Number of enrolments of both sexes of Small states in 2008 and the Number of enrolments of both sexes of Montenegro in 2011?
Provide a succinct answer. 2.16e+06. What is the difference between the Number of enrolments of both sexes of Small states in 2008 and the Number of enrolments of both sexes of Pakistan in 2011?
Offer a very short reply. -7.72e+06. What is the difference between the Number of enrolments of both sexes in Small states in 2008 and the Number of enrolments of both sexes in Sweden in 2011?
Your response must be concise. 1.52e+06. What is the difference between the Number of enrolments of both sexes of Montenegro in 2008 and the Number of enrolments of both sexes of Pakistan in 2011?
Provide a succinct answer. -9.87e+06. What is the difference between the Number of enrolments of both sexes in Montenegro in 2008 and the Number of enrolments of both sexes in Sweden in 2011?
Keep it short and to the point. -6.32e+05. What is the difference between the Number of enrolments of both sexes in Pakistan in 2008 and the Number of enrolments of both sexes in Sweden in 2011?
Give a very brief answer. 8.64e+06. What is the difference between the Number of enrolments of both sexes of Small states in 2008 and the Number of enrolments of both sexes of Montenegro in 2012?
Your answer should be compact. 2.16e+06. What is the difference between the Number of enrolments of both sexes of Small states in 2008 and the Number of enrolments of both sexes of Pakistan in 2012?
Provide a short and direct response. -8.15e+06. What is the difference between the Number of enrolments of both sexes in Small states in 2008 and the Number of enrolments of both sexes in Sweden in 2012?
Give a very brief answer. 1.54e+06. What is the difference between the Number of enrolments of both sexes in Montenegro in 2008 and the Number of enrolments of both sexes in Pakistan in 2012?
Provide a short and direct response. -1.03e+07. What is the difference between the Number of enrolments of both sexes in Montenegro in 2008 and the Number of enrolments of both sexes in Sweden in 2012?
Your response must be concise. -6.09e+05. What is the difference between the Number of enrolments of both sexes of Pakistan in 2008 and the Number of enrolments of both sexes of Sweden in 2012?
Offer a very short reply. 8.66e+06. What is the difference between the Number of enrolments of both sexes of Small states in 2009 and the Number of enrolments of both sexes of Montenegro in 2010?
Keep it short and to the point. 2.21e+06. What is the difference between the Number of enrolments of both sexes in Small states in 2009 and the Number of enrolments of both sexes in Pakistan in 2010?
Offer a terse response. -7.38e+06. What is the difference between the Number of enrolments of both sexes of Small states in 2009 and the Number of enrolments of both sexes of Sweden in 2010?
Make the answer very short. 1.54e+06. What is the difference between the Number of enrolments of both sexes in Montenegro in 2009 and the Number of enrolments of both sexes in Pakistan in 2010?
Provide a succinct answer. -9.59e+06. What is the difference between the Number of enrolments of both sexes of Montenegro in 2009 and the Number of enrolments of both sexes of Sweden in 2010?
Give a very brief answer. -6.63e+05. What is the difference between the Number of enrolments of both sexes in Pakistan in 2009 and the Number of enrolments of both sexes in Sweden in 2010?
Offer a very short reply. 8.70e+06. What is the difference between the Number of enrolments of both sexes in Small states in 2009 and the Number of enrolments of both sexes in Montenegro in 2011?
Offer a very short reply. 2.21e+06. What is the difference between the Number of enrolments of both sexes in Small states in 2009 and the Number of enrolments of both sexes in Pakistan in 2011?
Offer a terse response. -7.66e+06. What is the difference between the Number of enrolments of both sexes in Small states in 2009 and the Number of enrolments of both sexes in Sweden in 2011?
Give a very brief answer. 1.58e+06. What is the difference between the Number of enrolments of both sexes in Montenegro in 2009 and the Number of enrolments of both sexes in Pakistan in 2011?
Offer a terse response. -9.87e+06. What is the difference between the Number of enrolments of both sexes in Montenegro in 2009 and the Number of enrolments of both sexes in Sweden in 2011?
Provide a succinct answer. -6.31e+05. What is the difference between the Number of enrolments of both sexes of Pakistan in 2009 and the Number of enrolments of both sexes of Sweden in 2011?
Offer a very short reply. 8.73e+06. What is the difference between the Number of enrolments of both sexes of Small states in 2009 and the Number of enrolments of both sexes of Montenegro in 2012?
Offer a very short reply. 2.21e+06. What is the difference between the Number of enrolments of both sexes of Small states in 2009 and the Number of enrolments of both sexes of Pakistan in 2012?
Keep it short and to the point. -8.10e+06. What is the difference between the Number of enrolments of both sexes in Small states in 2009 and the Number of enrolments of both sexes in Sweden in 2012?
Give a very brief answer. 1.60e+06. What is the difference between the Number of enrolments of both sexes of Montenegro in 2009 and the Number of enrolments of both sexes of Pakistan in 2012?
Give a very brief answer. -1.03e+07. What is the difference between the Number of enrolments of both sexes of Montenegro in 2009 and the Number of enrolments of both sexes of Sweden in 2012?
Ensure brevity in your answer.  -6.08e+05. What is the difference between the Number of enrolments of both sexes of Pakistan in 2009 and the Number of enrolments of both sexes of Sweden in 2012?
Your answer should be very brief. 8.76e+06. What is the difference between the Number of enrolments of both sexes of Small states in 2010 and the Number of enrolments of both sexes of Montenegro in 2011?
Your answer should be compact. 2.26e+06. What is the difference between the Number of enrolments of both sexes of Small states in 2010 and the Number of enrolments of both sexes of Pakistan in 2011?
Offer a terse response. -7.62e+06. What is the difference between the Number of enrolments of both sexes in Small states in 2010 and the Number of enrolments of both sexes in Sweden in 2011?
Provide a succinct answer. 1.62e+06. What is the difference between the Number of enrolments of both sexes of Montenegro in 2010 and the Number of enrolments of both sexes of Pakistan in 2011?
Your answer should be very brief. -9.87e+06. What is the difference between the Number of enrolments of both sexes in Montenegro in 2010 and the Number of enrolments of both sexes in Sweden in 2011?
Offer a very short reply. -6.29e+05. What is the difference between the Number of enrolments of both sexes of Pakistan in 2010 and the Number of enrolments of both sexes of Sweden in 2011?
Make the answer very short. 8.96e+06. What is the difference between the Number of enrolments of both sexes of Small states in 2010 and the Number of enrolments of both sexes of Montenegro in 2012?
Your answer should be very brief. 2.26e+06. What is the difference between the Number of enrolments of both sexes of Small states in 2010 and the Number of enrolments of both sexes of Pakistan in 2012?
Your answer should be compact. -8.05e+06. What is the difference between the Number of enrolments of both sexes of Small states in 2010 and the Number of enrolments of both sexes of Sweden in 2012?
Your response must be concise. 1.64e+06. What is the difference between the Number of enrolments of both sexes in Montenegro in 2010 and the Number of enrolments of both sexes in Pakistan in 2012?
Your answer should be very brief. -1.03e+07. What is the difference between the Number of enrolments of both sexes of Montenegro in 2010 and the Number of enrolments of both sexes of Sweden in 2012?
Offer a terse response. -6.06e+05. What is the difference between the Number of enrolments of both sexes in Pakistan in 2010 and the Number of enrolments of both sexes in Sweden in 2012?
Your response must be concise. 8.98e+06. What is the difference between the Number of enrolments of both sexes in Small states in 2011 and the Number of enrolments of both sexes in Montenegro in 2012?
Keep it short and to the point. 2.30e+06. What is the difference between the Number of enrolments of both sexes of Small states in 2011 and the Number of enrolments of both sexes of Pakistan in 2012?
Offer a very short reply. -8.01e+06. What is the difference between the Number of enrolments of both sexes in Small states in 2011 and the Number of enrolments of both sexes in Sweden in 2012?
Provide a short and direct response. 1.68e+06. What is the difference between the Number of enrolments of both sexes in Montenegro in 2011 and the Number of enrolments of both sexes in Pakistan in 2012?
Make the answer very short. -1.03e+07. What is the difference between the Number of enrolments of both sexes in Montenegro in 2011 and the Number of enrolments of both sexes in Sweden in 2012?
Your response must be concise. -6.12e+05. What is the difference between the Number of enrolments of both sexes of Pakistan in 2011 and the Number of enrolments of both sexes of Sweden in 2012?
Provide a succinct answer. 9.26e+06. What is the average Number of enrolments of both sexes of Small states per year?
Your answer should be compact. 2.24e+06. What is the average Number of enrolments of both sexes in Montenegro per year?
Keep it short and to the point. 6.70e+04. What is the average Number of enrolments of both sexes in Pakistan per year?
Your response must be concise. 9.14e+06. What is the average Number of enrolments of both sexes of Sweden per year?
Keep it short and to the point. 7.34e+05. In the year 2005, what is the difference between the Number of enrolments of both sexes in Small states and Number of enrolments of both sexes in Montenegro?
Your answer should be very brief. 1.99e+06. In the year 2005, what is the difference between the Number of enrolments of both sexes of Small states and Number of enrolments of both sexes of Pakistan?
Your response must be concise. -4.79e+06. In the year 2005, what is the difference between the Number of enrolments of both sexes in Small states and Number of enrolments of both sexes in Sweden?
Your answer should be compact. 1.33e+06. In the year 2005, what is the difference between the Number of enrolments of both sexes of Montenegro and Number of enrolments of both sexes of Pakistan?
Offer a terse response. -6.78e+06. In the year 2005, what is the difference between the Number of enrolments of both sexes in Montenegro and Number of enrolments of both sexes in Sweden?
Give a very brief answer. -6.67e+05. In the year 2005, what is the difference between the Number of enrolments of both sexes of Pakistan and Number of enrolments of both sexes of Sweden?
Your response must be concise. 6.12e+06. In the year 2006, what is the difference between the Number of enrolments of both sexes of Small states and Number of enrolments of both sexes of Montenegro?
Provide a succinct answer. 2.05e+06. In the year 2006, what is the difference between the Number of enrolments of both sexes of Small states and Number of enrolments of both sexes of Pakistan?
Your answer should be very brief. -6.30e+06. In the year 2006, what is the difference between the Number of enrolments of both sexes of Small states and Number of enrolments of both sexes of Sweden?
Provide a short and direct response. 1.37e+06. In the year 2006, what is the difference between the Number of enrolments of both sexes of Montenegro and Number of enrolments of both sexes of Pakistan?
Provide a short and direct response. -8.35e+06. In the year 2006, what is the difference between the Number of enrolments of both sexes in Montenegro and Number of enrolments of both sexes in Sweden?
Your answer should be compact. -6.82e+05. In the year 2006, what is the difference between the Number of enrolments of both sexes in Pakistan and Number of enrolments of both sexes in Sweden?
Your response must be concise. 7.67e+06. In the year 2007, what is the difference between the Number of enrolments of both sexes of Small states and Number of enrolments of both sexes of Montenegro?
Give a very brief answer. 2.10e+06. In the year 2007, what is the difference between the Number of enrolments of both sexes of Small states and Number of enrolments of both sexes of Pakistan?
Ensure brevity in your answer.  -6.97e+06. In the year 2007, what is the difference between the Number of enrolments of both sexes in Small states and Number of enrolments of both sexes in Sweden?
Provide a succinct answer. 1.41e+06. In the year 2007, what is the difference between the Number of enrolments of both sexes of Montenegro and Number of enrolments of both sexes of Pakistan?
Ensure brevity in your answer.  -9.08e+06. In the year 2007, what is the difference between the Number of enrolments of both sexes in Montenegro and Number of enrolments of both sexes in Sweden?
Your answer should be compact. -6.93e+05. In the year 2007, what is the difference between the Number of enrolments of both sexes of Pakistan and Number of enrolments of both sexes of Sweden?
Ensure brevity in your answer.  8.38e+06. In the year 2008, what is the difference between the Number of enrolments of both sexes of Small states and Number of enrolments of both sexes of Montenegro?
Offer a terse response. 2.15e+06. In the year 2008, what is the difference between the Number of enrolments of both sexes in Small states and Number of enrolments of both sexes in Pakistan?
Your answer should be very brief. -7.12e+06. In the year 2008, what is the difference between the Number of enrolments of both sexes of Small states and Number of enrolments of both sexes of Sweden?
Offer a terse response. 1.46e+06. In the year 2008, what is the difference between the Number of enrolments of both sexes in Montenegro and Number of enrolments of both sexes in Pakistan?
Your answer should be very brief. -9.27e+06. In the year 2008, what is the difference between the Number of enrolments of both sexes in Montenegro and Number of enrolments of both sexes in Sweden?
Provide a succinct answer. -6.97e+05. In the year 2008, what is the difference between the Number of enrolments of both sexes in Pakistan and Number of enrolments of both sexes in Sweden?
Keep it short and to the point. 8.58e+06. In the year 2009, what is the difference between the Number of enrolments of both sexes of Small states and Number of enrolments of both sexes of Montenegro?
Provide a short and direct response. 2.21e+06. In the year 2009, what is the difference between the Number of enrolments of both sexes in Small states and Number of enrolments of both sexes in Pakistan?
Provide a succinct answer. -7.16e+06. In the year 2009, what is the difference between the Number of enrolments of both sexes of Small states and Number of enrolments of both sexes of Sweden?
Offer a terse response. 1.52e+06. In the year 2009, what is the difference between the Number of enrolments of both sexes in Montenegro and Number of enrolments of both sexes in Pakistan?
Give a very brief answer. -9.36e+06. In the year 2009, what is the difference between the Number of enrolments of both sexes in Montenegro and Number of enrolments of both sexes in Sweden?
Provide a short and direct response. -6.84e+05. In the year 2009, what is the difference between the Number of enrolments of both sexes of Pakistan and Number of enrolments of both sexes of Sweden?
Make the answer very short. 8.68e+06. In the year 2010, what is the difference between the Number of enrolments of both sexes of Small states and Number of enrolments of both sexes of Montenegro?
Provide a succinct answer. 2.25e+06. In the year 2010, what is the difference between the Number of enrolments of both sexes of Small states and Number of enrolments of both sexes of Pakistan?
Offer a very short reply. -7.33e+06. In the year 2010, what is the difference between the Number of enrolments of both sexes in Small states and Number of enrolments of both sexes in Sweden?
Make the answer very short. 1.59e+06. In the year 2010, what is the difference between the Number of enrolments of both sexes in Montenegro and Number of enrolments of both sexes in Pakistan?
Your answer should be very brief. -9.59e+06. In the year 2010, what is the difference between the Number of enrolments of both sexes in Montenegro and Number of enrolments of both sexes in Sweden?
Your response must be concise. -6.62e+05. In the year 2010, what is the difference between the Number of enrolments of both sexes of Pakistan and Number of enrolments of both sexes of Sweden?
Your answer should be compact. 8.92e+06. In the year 2011, what is the difference between the Number of enrolments of both sexes of Small states and Number of enrolments of both sexes of Montenegro?
Your answer should be very brief. 2.29e+06. In the year 2011, what is the difference between the Number of enrolments of both sexes of Small states and Number of enrolments of both sexes of Pakistan?
Ensure brevity in your answer.  -7.58e+06. In the year 2011, what is the difference between the Number of enrolments of both sexes of Small states and Number of enrolments of both sexes of Sweden?
Your answer should be compact. 1.66e+06. In the year 2011, what is the difference between the Number of enrolments of both sexes in Montenegro and Number of enrolments of both sexes in Pakistan?
Ensure brevity in your answer.  -9.88e+06. In the year 2011, what is the difference between the Number of enrolments of both sexes in Montenegro and Number of enrolments of both sexes in Sweden?
Provide a short and direct response. -6.35e+05. In the year 2011, what is the difference between the Number of enrolments of both sexes of Pakistan and Number of enrolments of both sexes of Sweden?
Your answer should be very brief. 9.24e+06. In the year 2012, what is the difference between the Number of enrolments of both sexes of Small states and Number of enrolments of both sexes of Montenegro?
Give a very brief answer. 2.30e+06. In the year 2012, what is the difference between the Number of enrolments of both sexes of Small states and Number of enrolments of both sexes of Pakistan?
Offer a very short reply. -8.01e+06. In the year 2012, what is the difference between the Number of enrolments of both sexes of Small states and Number of enrolments of both sexes of Sweden?
Ensure brevity in your answer.  1.69e+06. In the year 2012, what is the difference between the Number of enrolments of both sexes in Montenegro and Number of enrolments of both sexes in Pakistan?
Your answer should be very brief. -1.03e+07. In the year 2012, what is the difference between the Number of enrolments of both sexes of Montenegro and Number of enrolments of both sexes of Sweden?
Make the answer very short. -6.13e+05. In the year 2012, what is the difference between the Number of enrolments of both sexes of Pakistan and Number of enrolments of both sexes of Sweden?
Provide a short and direct response. 9.70e+06. What is the ratio of the Number of enrolments of both sexes of Small states in 2005 to that in 2006?
Offer a very short reply. 0.97. What is the ratio of the Number of enrolments of both sexes of Montenegro in 2005 to that in 2006?
Offer a very short reply. 1. What is the ratio of the Number of enrolments of both sexes in Pakistan in 2005 to that in 2006?
Your answer should be very brief. 0.81. What is the ratio of the Number of enrolments of both sexes of Sweden in 2005 to that in 2006?
Give a very brief answer. 0.98. What is the ratio of the Number of enrolments of both sexes of Small states in 2005 to that in 2007?
Keep it short and to the point. 0.95. What is the ratio of the Number of enrolments of both sexes in Montenegro in 2005 to that in 2007?
Provide a short and direct response. 1.01. What is the ratio of the Number of enrolments of both sexes in Pakistan in 2005 to that in 2007?
Offer a terse response. 0.75. What is the ratio of the Number of enrolments of both sexes of Sweden in 2005 to that in 2007?
Ensure brevity in your answer.  0.97. What is the ratio of the Number of enrolments of both sexes in Small states in 2005 to that in 2008?
Offer a terse response. 0.93. What is the ratio of the Number of enrolments of both sexes of Montenegro in 2005 to that in 2008?
Offer a very short reply. 1.02. What is the ratio of the Number of enrolments of both sexes in Pakistan in 2005 to that in 2008?
Your response must be concise. 0.73. What is the ratio of the Number of enrolments of both sexes in Sweden in 2005 to that in 2008?
Provide a short and direct response. 0.96. What is the ratio of the Number of enrolments of both sexes of Small states in 2005 to that in 2009?
Your answer should be compact. 0.91. What is the ratio of the Number of enrolments of both sexes in Montenegro in 2005 to that in 2009?
Your answer should be very brief. 1. What is the ratio of the Number of enrolments of both sexes in Pakistan in 2005 to that in 2009?
Make the answer very short. 0.73. What is the ratio of the Number of enrolments of both sexes of Sweden in 2005 to that in 2009?
Your answer should be compact. 0.98. What is the ratio of the Number of enrolments of both sexes in Small states in 2005 to that in 2010?
Provide a succinct answer. 0.89. What is the ratio of the Number of enrolments of both sexes in Montenegro in 2005 to that in 2010?
Your answer should be compact. 0.98. What is the ratio of the Number of enrolments of both sexes of Pakistan in 2005 to that in 2010?
Ensure brevity in your answer.  0.71. What is the ratio of the Number of enrolments of both sexes of Small states in 2005 to that in 2011?
Ensure brevity in your answer.  0.87. What is the ratio of the Number of enrolments of both sexes of Montenegro in 2005 to that in 2011?
Provide a short and direct response. 1.07. What is the ratio of the Number of enrolments of both sexes of Pakistan in 2005 to that in 2011?
Keep it short and to the point. 0.69. What is the ratio of the Number of enrolments of both sexes in Sweden in 2005 to that in 2011?
Offer a terse response. 1.05. What is the ratio of the Number of enrolments of both sexes in Small states in 2005 to that in 2012?
Make the answer very short. 0.87. What is the ratio of the Number of enrolments of both sexes of Montenegro in 2005 to that in 2012?
Your response must be concise. 1.09. What is the ratio of the Number of enrolments of both sexes in Pakistan in 2005 to that in 2012?
Ensure brevity in your answer.  0.66. What is the ratio of the Number of enrolments of both sexes of Sweden in 2005 to that in 2012?
Your answer should be very brief. 1.09. What is the ratio of the Number of enrolments of both sexes of Small states in 2006 to that in 2007?
Your response must be concise. 0.98. What is the ratio of the Number of enrolments of both sexes of Montenegro in 2006 to that in 2007?
Provide a succinct answer. 1.01. What is the ratio of the Number of enrolments of both sexes in Pakistan in 2006 to that in 2007?
Provide a short and direct response. 0.92. What is the ratio of the Number of enrolments of both sexes in Small states in 2006 to that in 2008?
Make the answer very short. 0.96. What is the ratio of the Number of enrolments of both sexes of Montenegro in 2006 to that in 2008?
Keep it short and to the point. 1.02. What is the ratio of the Number of enrolments of both sexes of Pakistan in 2006 to that in 2008?
Your response must be concise. 0.9. What is the ratio of the Number of enrolments of both sexes in Sweden in 2006 to that in 2008?
Your answer should be compact. 0.98. What is the ratio of the Number of enrolments of both sexes of Small states in 2006 to that in 2009?
Your answer should be compact. 0.93. What is the ratio of the Number of enrolments of both sexes in Pakistan in 2006 to that in 2009?
Provide a short and direct response. 0.89. What is the ratio of the Number of enrolments of both sexes of Sweden in 2006 to that in 2009?
Make the answer very short. 1. What is the ratio of the Number of enrolments of both sexes of Small states in 2006 to that in 2010?
Your response must be concise. 0.91. What is the ratio of the Number of enrolments of both sexes of Montenegro in 2006 to that in 2010?
Ensure brevity in your answer.  0.98. What is the ratio of the Number of enrolments of both sexes of Pakistan in 2006 to that in 2010?
Keep it short and to the point. 0.87. What is the ratio of the Number of enrolments of both sexes of Sweden in 2006 to that in 2010?
Your answer should be compact. 1.03. What is the ratio of the Number of enrolments of both sexes in Small states in 2006 to that in 2011?
Give a very brief answer. 0.9. What is the ratio of the Number of enrolments of both sexes in Montenegro in 2006 to that in 2011?
Your response must be concise. 1.06. What is the ratio of the Number of enrolments of both sexes of Pakistan in 2006 to that in 2011?
Provide a succinct answer. 0.85. What is the ratio of the Number of enrolments of both sexes of Sweden in 2006 to that in 2011?
Your answer should be very brief. 1.07. What is the ratio of the Number of enrolments of both sexes in Small states in 2006 to that in 2012?
Your answer should be very brief. 0.9. What is the ratio of the Number of enrolments of both sexes in Montenegro in 2006 to that in 2012?
Your answer should be compact. 1.08. What is the ratio of the Number of enrolments of both sexes in Pakistan in 2006 to that in 2012?
Ensure brevity in your answer.  0.81. What is the ratio of the Number of enrolments of both sexes in Sweden in 2006 to that in 2012?
Your answer should be very brief. 1.11. What is the ratio of the Number of enrolments of both sexes in Small states in 2007 to that in 2008?
Your response must be concise. 0.98. What is the ratio of the Number of enrolments of both sexes in Pakistan in 2007 to that in 2008?
Provide a succinct answer. 0.98. What is the ratio of the Number of enrolments of both sexes of Small states in 2007 to that in 2009?
Your answer should be very brief. 0.95. What is the ratio of the Number of enrolments of both sexes in Montenegro in 2007 to that in 2009?
Your response must be concise. 0.99. What is the ratio of the Number of enrolments of both sexes of Pakistan in 2007 to that in 2009?
Keep it short and to the point. 0.97. What is the ratio of the Number of enrolments of both sexes of Sweden in 2007 to that in 2009?
Make the answer very short. 1.01. What is the ratio of the Number of enrolments of both sexes of Small states in 2007 to that in 2010?
Keep it short and to the point. 0.94. What is the ratio of the Number of enrolments of both sexes of Montenegro in 2007 to that in 2010?
Make the answer very short. 0.97. What is the ratio of the Number of enrolments of both sexes of Pakistan in 2007 to that in 2010?
Your answer should be compact. 0.95. What is the ratio of the Number of enrolments of both sexes of Small states in 2007 to that in 2011?
Make the answer very short. 0.92. What is the ratio of the Number of enrolments of both sexes of Montenegro in 2007 to that in 2011?
Offer a terse response. 1.05. What is the ratio of the Number of enrolments of both sexes in Pakistan in 2007 to that in 2011?
Provide a short and direct response. 0.92. What is the ratio of the Number of enrolments of both sexes of Sweden in 2007 to that in 2011?
Your response must be concise. 1.09. What is the ratio of the Number of enrolments of both sexes in Small states in 2007 to that in 2012?
Your response must be concise. 0.92. What is the ratio of the Number of enrolments of both sexes in Montenegro in 2007 to that in 2012?
Provide a short and direct response. 1.07. What is the ratio of the Number of enrolments of both sexes of Pakistan in 2007 to that in 2012?
Keep it short and to the point. 0.88. What is the ratio of the Number of enrolments of both sexes in Sweden in 2007 to that in 2012?
Your answer should be very brief. 1.13. What is the ratio of the Number of enrolments of both sexes in Small states in 2008 to that in 2009?
Offer a terse response. 0.98. What is the ratio of the Number of enrolments of both sexes of Montenegro in 2008 to that in 2009?
Give a very brief answer. 0.98. What is the ratio of the Number of enrolments of both sexes in Sweden in 2008 to that in 2009?
Offer a terse response. 1.02. What is the ratio of the Number of enrolments of both sexes in Small states in 2008 to that in 2010?
Offer a very short reply. 0.96. What is the ratio of the Number of enrolments of both sexes of Montenegro in 2008 to that in 2010?
Offer a very short reply. 0.96. What is the ratio of the Number of enrolments of both sexes of Pakistan in 2008 to that in 2010?
Your answer should be very brief. 0.97. What is the ratio of the Number of enrolments of both sexes in Sweden in 2008 to that in 2010?
Keep it short and to the point. 1.05. What is the ratio of the Number of enrolments of both sexes in Small states in 2008 to that in 2011?
Your response must be concise. 0.94. What is the ratio of the Number of enrolments of both sexes in Montenegro in 2008 to that in 2011?
Offer a very short reply. 1.04. What is the ratio of the Number of enrolments of both sexes of Pakistan in 2008 to that in 2011?
Offer a very short reply. 0.94. What is the ratio of the Number of enrolments of both sexes in Sweden in 2008 to that in 2011?
Keep it short and to the point. 1.09. What is the ratio of the Number of enrolments of both sexes of Small states in 2008 to that in 2012?
Your answer should be very brief. 0.94. What is the ratio of the Number of enrolments of both sexes in Montenegro in 2008 to that in 2012?
Offer a very short reply. 1.06. What is the ratio of the Number of enrolments of both sexes in Pakistan in 2008 to that in 2012?
Provide a short and direct response. 0.9. What is the ratio of the Number of enrolments of both sexes of Sweden in 2008 to that in 2012?
Give a very brief answer. 1.13. What is the ratio of the Number of enrolments of both sexes in Small states in 2009 to that in 2010?
Your response must be concise. 0.98. What is the ratio of the Number of enrolments of both sexes of Montenegro in 2009 to that in 2010?
Keep it short and to the point. 0.98. What is the ratio of the Number of enrolments of both sexes in Sweden in 2009 to that in 2010?
Give a very brief answer. 1.03. What is the ratio of the Number of enrolments of both sexes in Small states in 2009 to that in 2011?
Provide a succinct answer. 0.96. What is the ratio of the Number of enrolments of both sexes of Montenegro in 2009 to that in 2011?
Provide a succinct answer. 1.06. What is the ratio of the Number of enrolments of both sexes in Pakistan in 2009 to that in 2011?
Your response must be concise. 0.95. What is the ratio of the Number of enrolments of both sexes in Sweden in 2009 to that in 2011?
Your answer should be very brief. 1.08. What is the ratio of the Number of enrolments of both sexes of Small states in 2009 to that in 2012?
Offer a very short reply. 0.96. What is the ratio of the Number of enrolments of both sexes of Montenegro in 2009 to that in 2012?
Give a very brief answer. 1.08. What is the ratio of the Number of enrolments of both sexes of Pakistan in 2009 to that in 2012?
Offer a very short reply. 0.91. What is the ratio of the Number of enrolments of both sexes of Sweden in 2009 to that in 2012?
Make the answer very short. 1.11. What is the ratio of the Number of enrolments of both sexes in Small states in 2010 to that in 2011?
Provide a short and direct response. 0.98. What is the ratio of the Number of enrolments of both sexes of Montenegro in 2010 to that in 2011?
Your answer should be compact. 1.08. What is the ratio of the Number of enrolments of both sexes of Pakistan in 2010 to that in 2011?
Provide a short and direct response. 0.97. What is the ratio of the Number of enrolments of both sexes of Sweden in 2010 to that in 2011?
Ensure brevity in your answer.  1.05. What is the ratio of the Number of enrolments of both sexes in Small states in 2010 to that in 2012?
Your response must be concise. 0.98. What is the ratio of the Number of enrolments of both sexes of Montenegro in 2010 to that in 2012?
Provide a succinct answer. 1.1. What is the ratio of the Number of enrolments of both sexes of Pakistan in 2010 to that in 2012?
Your answer should be compact. 0.93. What is the ratio of the Number of enrolments of both sexes in Sweden in 2010 to that in 2012?
Provide a short and direct response. 1.08. What is the ratio of the Number of enrolments of both sexes in Small states in 2011 to that in 2012?
Offer a very short reply. 1. What is the ratio of the Number of enrolments of both sexes in Montenegro in 2011 to that in 2012?
Provide a short and direct response. 1.02. What is the ratio of the Number of enrolments of both sexes in Pakistan in 2011 to that in 2012?
Provide a short and direct response. 0.96. What is the ratio of the Number of enrolments of both sexes of Sweden in 2011 to that in 2012?
Offer a terse response. 1.03. What is the difference between the highest and the second highest Number of enrolments of both sexes of Small states?
Ensure brevity in your answer.  5352.25. What is the difference between the highest and the second highest Number of enrolments of both sexes in Montenegro?
Make the answer very short. 1148. What is the difference between the highest and the second highest Number of enrolments of both sexes in Pakistan?
Provide a succinct answer. 4.32e+05. What is the difference between the highest and the second highest Number of enrolments of both sexes in Sweden?
Give a very brief answer. 3773. What is the difference between the highest and the lowest Number of enrolments of both sexes of Small states?
Provide a succinct answer. 3.02e+05. What is the difference between the highest and the lowest Number of enrolments of both sexes of Montenegro?
Your answer should be compact. 6606. What is the difference between the highest and the lowest Number of enrolments of both sexes of Pakistan?
Ensure brevity in your answer.  3.52e+06. What is the difference between the highest and the lowest Number of enrolments of both sexes of Sweden?
Your response must be concise. 8.85e+04. 